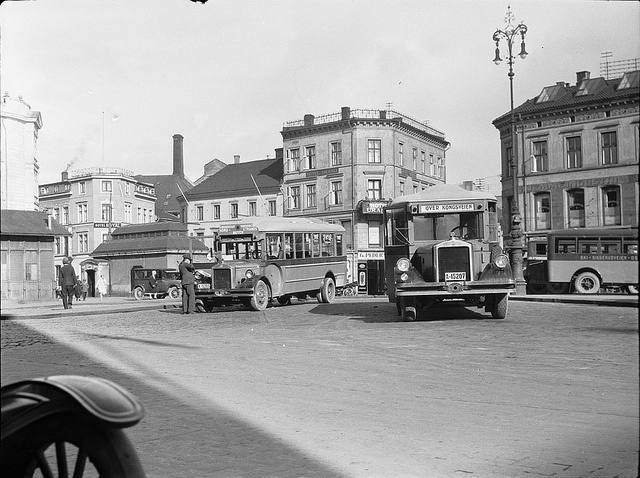Describe the objects in this image and their specific colors. I can see bus in black, gray, darkgray, and lightgray tones, bus in black, darkgray, gray, and lightgray tones, bus in black, gray, darkgray, and lightgray tones, people in black, gray, and lightgray tones, and people in black, gray, darkgray, and lightgray tones in this image. 